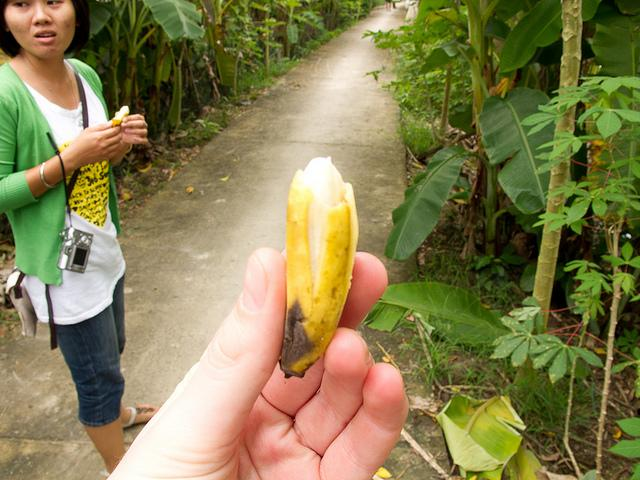The woman eating the fruit is likely on the path for what reason? Please explain your reasoning. tourism. She has a camera dangling from her wrist. 